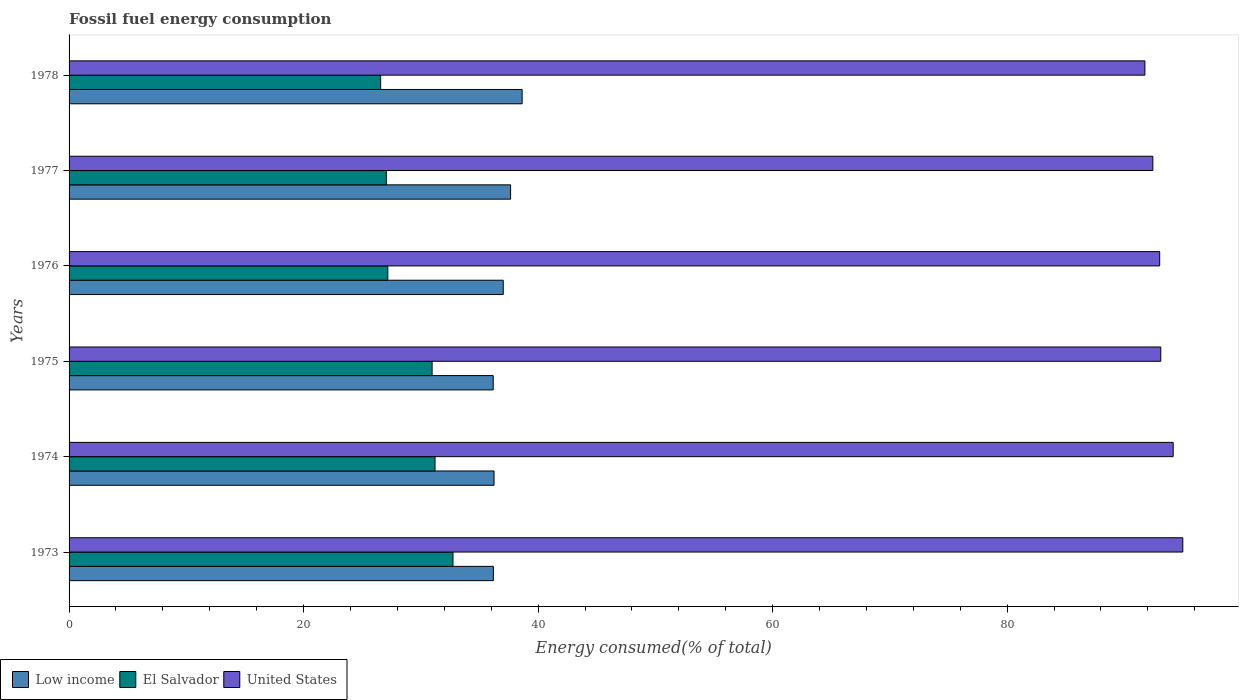How many different coloured bars are there?
Provide a short and direct response. 3. How many groups of bars are there?
Make the answer very short. 6. Are the number of bars per tick equal to the number of legend labels?
Offer a very short reply. Yes. How many bars are there on the 6th tick from the top?
Your answer should be compact. 3. What is the label of the 4th group of bars from the top?
Your answer should be very brief. 1975. In how many cases, is the number of bars for a given year not equal to the number of legend labels?
Keep it short and to the point. 0. What is the percentage of energy consumed in El Salvador in 1974?
Make the answer very short. 31.21. Across all years, what is the maximum percentage of energy consumed in United States?
Your answer should be compact. 94.98. Across all years, what is the minimum percentage of energy consumed in Low income?
Offer a very short reply. 36.17. In which year was the percentage of energy consumed in Low income maximum?
Your response must be concise. 1978. In which year was the percentage of energy consumed in Low income minimum?
Ensure brevity in your answer.  1975. What is the total percentage of energy consumed in United States in the graph?
Make the answer very short. 559.4. What is the difference between the percentage of energy consumed in El Salvador in 1973 and that in 1977?
Provide a short and direct response. 5.68. What is the difference between the percentage of energy consumed in El Salvador in 1977 and the percentage of energy consumed in Low income in 1973?
Offer a terse response. -9.13. What is the average percentage of energy consumed in El Salvador per year?
Offer a very short reply. 29.29. In the year 1978, what is the difference between the percentage of energy consumed in United States and percentage of energy consumed in Low income?
Offer a terse response. 53.11. In how many years, is the percentage of energy consumed in United States greater than 48 %?
Keep it short and to the point. 6. What is the ratio of the percentage of energy consumed in El Salvador in 1976 to that in 1978?
Your answer should be very brief. 1.02. Is the difference between the percentage of energy consumed in United States in 1974 and 1975 greater than the difference between the percentage of energy consumed in Low income in 1974 and 1975?
Provide a short and direct response. Yes. What is the difference between the highest and the second highest percentage of energy consumed in Low income?
Your response must be concise. 0.98. What is the difference between the highest and the lowest percentage of energy consumed in Low income?
Offer a terse response. 2.47. Is the sum of the percentage of energy consumed in El Salvador in 1974 and 1975 greater than the maximum percentage of energy consumed in United States across all years?
Your answer should be very brief. No. What does the 2nd bar from the top in 1975 represents?
Your answer should be very brief. El Salvador. What does the 2nd bar from the bottom in 1973 represents?
Your answer should be compact. El Salvador. Is it the case that in every year, the sum of the percentage of energy consumed in El Salvador and percentage of energy consumed in Low income is greater than the percentage of energy consumed in United States?
Offer a very short reply. No. How many bars are there?
Your response must be concise. 18. What is the difference between two consecutive major ticks on the X-axis?
Ensure brevity in your answer.  20. Does the graph contain any zero values?
Keep it short and to the point. No. Where does the legend appear in the graph?
Give a very brief answer. Bottom left. What is the title of the graph?
Make the answer very short. Fossil fuel energy consumption. Does "Thailand" appear as one of the legend labels in the graph?
Make the answer very short. No. What is the label or title of the X-axis?
Your answer should be very brief. Energy consumed(% of total). What is the label or title of the Y-axis?
Give a very brief answer. Years. What is the Energy consumed(% of total) in Low income in 1973?
Provide a short and direct response. 36.18. What is the Energy consumed(% of total) of El Salvador in 1973?
Provide a short and direct response. 32.74. What is the Energy consumed(% of total) of United States in 1973?
Provide a succinct answer. 94.98. What is the Energy consumed(% of total) of Low income in 1974?
Make the answer very short. 36.24. What is the Energy consumed(% of total) in El Salvador in 1974?
Provide a short and direct response. 31.21. What is the Energy consumed(% of total) in United States in 1974?
Offer a terse response. 94.16. What is the Energy consumed(% of total) of Low income in 1975?
Ensure brevity in your answer.  36.17. What is the Energy consumed(% of total) of El Salvador in 1975?
Provide a short and direct response. 30.96. What is the Energy consumed(% of total) in United States in 1975?
Make the answer very short. 93.1. What is the Energy consumed(% of total) in Low income in 1976?
Your response must be concise. 37.02. What is the Energy consumed(% of total) in El Salvador in 1976?
Your answer should be compact. 27.18. What is the Energy consumed(% of total) of United States in 1976?
Your response must be concise. 93.01. What is the Energy consumed(% of total) of Low income in 1977?
Your response must be concise. 37.65. What is the Energy consumed(% of total) of El Salvador in 1977?
Keep it short and to the point. 27.06. What is the Energy consumed(% of total) in United States in 1977?
Ensure brevity in your answer.  92.42. What is the Energy consumed(% of total) in Low income in 1978?
Offer a terse response. 38.64. What is the Energy consumed(% of total) in El Salvador in 1978?
Your answer should be compact. 26.57. What is the Energy consumed(% of total) in United States in 1978?
Offer a very short reply. 91.74. Across all years, what is the maximum Energy consumed(% of total) in Low income?
Your response must be concise. 38.64. Across all years, what is the maximum Energy consumed(% of total) of El Salvador?
Ensure brevity in your answer.  32.74. Across all years, what is the maximum Energy consumed(% of total) of United States?
Your answer should be compact. 94.98. Across all years, what is the minimum Energy consumed(% of total) of Low income?
Offer a terse response. 36.17. Across all years, what is the minimum Energy consumed(% of total) of El Salvador?
Offer a very short reply. 26.57. Across all years, what is the minimum Energy consumed(% of total) of United States?
Your answer should be compact. 91.74. What is the total Energy consumed(% of total) in Low income in the graph?
Provide a short and direct response. 221.91. What is the total Energy consumed(% of total) in El Salvador in the graph?
Your answer should be very brief. 175.72. What is the total Energy consumed(% of total) in United States in the graph?
Your answer should be very brief. 559.4. What is the difference between the Energy consumed(% of total) in Low income in 1973 and that in 1974?
Your response must be concise. -0.06. What is the difference between the Energy consumed(% of total) in El Salvador in 1973 and that in 1974?
Ensure brevity in your answer.  1.53. What is the difference between the Energy consumed(% of total) of United States in 1973 and that in 1974?
Ensure brevity in your answer.  0.82. What is the difference between the Energy consumed(% of total) in Low income in 1973 and that in 1975?
Your answer should be very brief. 0.02. What is the difference between the Energy consumed(% of total) in El Salvador in 1973 and that in 1975?
Provide a succinct answer. 1.78. What is the difference between the Energy consumed(% of total) in United States in 1973 and that in 1975?
Provide a short and direct response. 1.88. What is the difference between the Energy consumed(% of total) of Low income in 1973 and that in 1976?
Your response must be concise. -0.84. What is the difference between the Energy consumed(% of total) of El Salvador in 1973 and that in 1976?
Ensure brevity in your answer.  5.56. What is the difference between the Energy consumed(% of total) of United States in 1973 and that in 1976?
Give a very brief answer. 1.97. What is the difference between the Energy consumed(% of total) of Low income in 1973 and that in 1977?
Give a very brief answer. -1.47. What is the difference between the Energy consumed(% of total) in El Salvador in 1973 and that in 1977?
Offer a terse response. 5.68. What is the difference between the Energy consumed(% of total) of United States in 1973 and that in 1977?
Ensure brevity in your answer.  2.55. What is the difference between the Energy consumed(% of total) in Low income in 1973 and that in 1978?
Offer a terse response. -2.45. What is the difference between the Energy consumed(% of total) in El Salvador in 1973 and that in 1978?
Provide a short and direct response. 6.17. What is the difference between the Energy consumed(% of total) in United States in 1973 and that in 1978?
Provide a short and direct response. 3.23. What is the difference between the Energy consumed(% of total) in Low income in 1974 and that in 1975?
Ensure brevity in your answer.  0.07. What is the difference between the Energy consumed(% of total) of El Salvador in 1974 and that in 1975?
Your response must be concise. 0.25. What is the difference between the Energy consumed(% of total) of United States in 1974 and that in 1975?
Your answer should be compact. 1.06. What is the difference between the Energy consumed(% of total) in Low income in 1974 and that in 1976?
Your response must be concise. -0.79. What is the difference between the Energy consumed(% of total) of El Salvador in 1974 and that in 1976?
Keep it short and to the point. 4.03. What is the difference between the Energy consumed(% of total) in United States in 1974 and that in 1976?
Your answer should be very brief. 1.15. What is the difference between the Energy consumed(% of total) in Low income in 1974 and that in 1977?
Provide a short and direct response. -1.41. What is the difference between the Energy consumed(% of total) of El Salvador in 1974 and that in 1977?
Provide a short and direct response. 4.15. What is the difference between the Energy consumed(% of total) of United States in 1974 and that in 1977?
Offer a terse response. 1.73. What is the difference between the Energy consumed(% of total) in Low income in 1974 and that in 1978?
Make the answer very short. -2.4. What is the difference between the Energy consumed(% of total) in El Salvador in 1974 and that in 1978?
Ensure brevity in your answer.  4.64. What is the difference between the Energy consumed(% of total) of United States in 1974 and that in 1978?
Your response must be concise. 2.41. What is the difference between the Energy consumed(% of total) of Low income in 1975 and that in 1976?
Offer a terse response. -0.86. What is the difference between the Energy consumed(% of total) in El Salvador in 1975 and that in 1976?
Ensure brevity in your answer.  3.78. What is the difference between the Energy consumed(% of total) of United States in 1975 and that in 1976?
Your answer should be compact. 0.09. What is the difference between the Energy consumed(% of total) of Low income in 1975 and that in 1977?
Ensure brevity in your answer.  -1.48. What is the difference between the Energy consumed(% of total) in El Salvador in 1975 and that in 1977?
Offer a very short reply. 3.9. What is the difference between the Energy consumed(% of total) in United States in 1975 and that in 1977?
Your response must be concise. 0.68. What is the difference between the Energy consumed(% of total) in Low income in 1975 and that in 1978?
Offer a very short reply. -2.47. What is the difference between the Energy consumed(% of total) of El Salvador in 1975 and that in 1978?
Offer a terse response. 4.39. What is the difference between the Energy consumed(% of total) of United States in 1975 and that in 1978?
Give a very brief answer. 1.35. What is the difference between the Energy consumed(% of total) of Low income in 1976 and that in 1977?
Ensure brevity in your answer.  -0.63. What is the difference between the Energy consumed(% of total) in El Salvador in 1976 and that in 1977?
Give a very brief answer. 0.13. What is the difference between the Energy consumed(% of total) of United States in 1976 and that in 1977?
Offer a very short reply. 0.58. What is the difference between the Energy consumed(% of total) in Low income in 1976 and that in 1978?
Give a very brief answer. -1.61. What is the difference between the Energy consumed(% of total) of El Salvador in 1976 and that in 1978?
Offer a very short reply. 0.61. What is the difference between the Energy consumed(% of total) of United States in 1976 and that in 1978?
Provide a short and direct response. 1.26. What is the difference between the Energy consumed(% of total) in Low income in 1977 and that in 1978?
Ensure brevity in your answer.  -0.98. What is the difference between the Energy consumed(% of total) in El Salvador in 1977 and that in 1978?
Offer a terse response. 0.49. What is the difference between the Energy consumed(% of total) of United States in 1977 and that in 1978?
Make the answer very short. 0.68. What is the difference between the Energy consumed(% of total) in Low income in 1973 and the Energy consumed(% of total) in El Salvador in 1974?
Give a very brief answer. 4.98. What is the difference between the Energy consumed(% of total) in Low income in 1973 and the Energy consumed(% of total) in United States in 1974?
Your response must be concise. -57.97. What is the difference between the Energy consumed(% of total) of El Salvador in 1973 and the Energy consumed(% of total) of United States in 1974?
Offer a very short reply. -61.42. What is the difference between the Energy consumed(% of total) of Low income in 1973 and the Energy consumed(% of total) of El Salvador in 1975?
Give a very brief answer. 5.22. What is the difference between the Energy consumed(% of total) in Low income in 1973 and the Energy consumed(% of total) in United States in 1975?
Your answer should be very brief. -56.91. What is the difference between the Energy consumed(% of total) of El Salvador in 1973 and the Energy consumed(% of total) of United States in 1975?
Your answer should be compact. -60.36. What is the difference between the Energy consumed(% of total) in Low income in 1973 and the Energy consumed(% of total) in El Salvador in 1976?
Your response must be concise. 9. What is the difference between the Energy consumed(% of total) in Low income in 1973 and the Energy consumed(% of total) in United States in 1976?
Provide a short and direct response. -56.82. What is the difference between the Energy consumed(% of total) in El Salvador in 1973 and the Energy consumed(% of total) in United States in 1976?
Provide a short and direct response. -60.27. What is the difference between the Energy consumed(% of total) in Low income in 1973 and the Energy consumed(% of total) in El Salvador in 1977?
Provide a short and direct response. 9.13. What is the difference between the Energy consumed(% of total) of Low income in 1973 and the Energy consumed(% of total) of United States in 1977?
Keep it short and to the point. -56.24. What is the difference between the Energy consumed(% of total) in El Salvador in 1973 and the Energy consumed(% of total) in United States in 1977?
Keep it short and to the point. -59.68. What is the difference between the Energy consumed(% of total) of Low income in 1973 and the Energy consumed(% of total) of El Salvador in 1978?
Your response must be concise. 9.61. What is the difference between the Energy consumed(% of total) of Low income in 1973 and the Energy consumed(% of total) of United States in 1978?
Provide a succinct answer. -55.56. What is the difference between the Energy consumed(% of total) in El Salvador in 1973 and the Energy consumed(% of total) in United States in 1978?
Give a very brief answer. -59. What is the difference between the Energy consumed(% of total) in Low income in 1974 and the Energy consumed(% of total) in El Salvador in 1975?
Offer a terse response. 5.28. What is the difference between the Energy consumed(% of total) of Low income in 1974 and the Energy consumed(% of total) of United States in 1975?
Ensure brevity in your answer.  -56.86. What is the difference between the Energy consumed(% of total) of El Salvador in 1974 and the Energy consumed(% of total) of United States in 1975?
Provide a short and direct response. -61.89. What is the difference between the Energy consumed(% of total) of Low income in 1974 and the Energy consumed(% of total) of El Salvador in 1976?
Provide a succinct answer. 9.06. What is the difference between the Energy consumed(% of total) of Low income in 1974 and the Energy consumed(% of total) of United States in 1976?
Provide a short and direct response. -56.77. What is the difference between the Energy consumed(% of total) of El Salvador in 1974 and the Energy consumed(% of total) of United States in 1976?
Make the answer very short. -61.8. What is the difference between the Energy consumed(% of total) in Low income in 1974 and the Energy consumed(% of total) in El Salvador in 1977?
Offer a very short reply. 9.18. What is the difference between the Energy consumed(% of total) in Low income in 1974 and the Energy consumed(% of total) in United States in 1977?
Ensure brevity in your answer.  -56.18. What is the difference between the Energy consumed(% of total) in El Salvador in 1974 and the Energy consumed(% of total) in United States in 1977?
Offer a terse response. -61.21. What is the difference between the Energy consumed(% of total) in Low income in 1974 and the Energy consumed(% of total) in El Salvador in 1978?
Offer a terse response. 9.67. What is the difference between the Energy consumed(% of total) of Low income in 1974 and the Energy consumed(% of total) of United States in 1978?
Your answer should be very brief. -55.5. What is the difference between the Energy consumed(% of total) in El Salvador in 1974 and the Energy consumed(% of total) in United States in 1978?
Offer a very short reply. -60.54. What is the difference between the Energy consumed(% of total) in Low income in 1975 and the Energy consumed(% of total) in El Salvador in 1976?
Ensure brevity in your answer.  8.99. What is the difference between the Energy consumed(% of total) in Low income in 1975 and the Energy consumed(% of total) in United States in 1976?
Your answer should be compact. -56.84. What is the difference between the Energy consumed(% of total) in El Salvador in 1975 and the Energy consumed(% of total) in United States in 1976?
Offer a very short reply. -62.05. What is the difference between the Energy consumed(% of total) in Low income in 1975 and the Energy consumed(% of total) in El Salvador in 1977?
Make the answer very short. 9.11. What is the difference between the Energy consumed(% of total) of Low income in 1975 and the Energy consumed(% of total) of United States in 1977?
Provide a succinct answer. -56.25. What is the difference between the Energy consumed(% of total) of El Salvador in 1975 and the Energy consumed(% of total) of United States in 1977?
Provide a short and direct response. -61.46. What is the difference between the Energy consumed(% of total) in Low income in 1975 and the Energy consumed(% of total) in El Salvador in 1978?
Your response must be concise. 9.6. What is the difference between the Energy consumed(% of total) in Low income in 1975 and the Energy consumed(% of total) in United States in 1978?
Offer a very short reply. -55.58. What is the difference between the Energy consumed(% of total) in El Salvador in 1975 and the Energy consumed(% of total) in United States in 1978?
Offer a very short reply. -60.78. What is the difference between the Energy consumed(% of total) of Low income in 1976 and the Energy consumed(% of total) of El Salvador in 1977?
Provide a succinct answer. 9.97. What is the difference between the Energy consumed(% of total) of Low income in 1976 and the Energy consumed(% of total) of United States in 1977?
Your answer should be compact. -55.4. What is the difference between the Energy consumed(% of total) of El Salvador in 1976 and the Energy consumed(% of total) of United States in 1977?
Provide a succinct answer. -65.24. What is the difference between the Energy consumed(% of total) in Low income in 1976 and the Energy consumed(% of total) in El Salvador in 1978?
Your answer should be compact. 10.45. What is the difference between the Energy consumed(% of total) in Low income in 1976 and the Energy consumed(% of total) in United States in 1978?
Your answer should be compact. -54.72. What is the difference between the Energy consumed(% of total) of El Salvador in 1976 and the Energy consumed(% of total) of United States in 1978?
Provide a succinct answer. -64.56. What is the difference between the Energy consumed(% of total) of Low income in 1977 and the Energy consumed(% of total) of El Salvador in 1978?
Provide a succinct answer. 11.08. What is the difference between the Energy consumed(% of total) in Low income in 1977 and the Energy consumed(% of total) in United States in 1978?
Offer a terse response. -54.09. What is the difference between the Energy consumed(% of total) in El Salvador in 1977 and the Energy consumed(% of total) in United States in 1978?
Provide a short and direct response. -64.69. What is the average Energy consumed(% of total) of Low income per year?
Provide a succinct answer. 36.98. What is the average Energy consumed(% of total) of El Salvador per year?
Offer a very short reply. 29.29. What is the average Energy consumed(% of total) of United States per year?
Your answer should be very brief. 93.23. In the year 1973, what is the difference between the Energy consumed(% of total) of Low income and Energy consumed(% of total) of El Salvador?
Provide a succinct answer. 3.44. In the year 1973, what is the difference between the Energy consumed(% of total) of Low income and Energy consumed(% of total) of United States?
Provide a succinct answer. -58.79. In the year 1973, what is the difference between the Energy consumed(% of total) in El Salvador and Energy consumed(% of total) in United States?
Offer a very short reply. -62.24. In the year 1974, what is the difference between the Energy consumed(% of total) in Low income and Energy consumed(% of total) in El Salvador?
Offer a terse response. 5.03. In the year 1974, what is the difference between the Energy consumed(% of total) in Low income and Energy consumed(% of total) in United States?
Offer a very short reply. -57.92. In the year 1974, what is the difference between the Energy consumed(% of total) of El Salvador and Energy consumed(% of total) of United States?
Your answer should be very brief. -62.95. In the year 1975, what is the difference between the Energy consumed(% of total) in Low income and Energy consumed(% of total) in El Salvador?
Your answer should be compact. 5.21. In the year 1975, what is the difference between the Energy consumed(% of total) in Low income and Energy consumed(% of total) in United States?
Ensure brevity in your answer.  -56.93. In the year 1975, what is the difference between the Energy consumed(% of total) of El Salvador and Energy consumed(% of total) of United States?
Offer a terse response. -62.14. In the year 1976, what is the difference between the Energy consumed(% of total) of Low income and Energy consumed(% of total) of El Salvador?
Ensure brevity in your answer.  9.84. In the year 1976, what is the difference between the Energy consumed(% of total) in Low income and Energy consumed(% of total) in United States?
Offer a terse response. -55.98. In the year 1976, what is the difference between the Energy consumed(% of total) in El Salvador and Energy consumed(% of total) in United States?
Your response must be concise. -65.82. In the year 1977, what is the difference between the Energy consumed(% of total) of Low income and Energy consumed(% of total) of El Salvador?
Give a very brief answer. 10.6. In the year 1977, what is the difference between the Energy consumed(% of total) in Low income and Energy consumed(% of total) in United States?
Provide a short and direct response. -54.77. In the year 1977, what is the difference between the Energy consumed(% of total) of El Salvador and Energy consumed(% of total) of United States?
Provide a short and direct response. -65.37. In the year 1978, what is the difference between the Energy consumed(% of total) in Low income and Energy consumed(% of total) in El Salvador?
Offer a terse response. 12.07. In the year 1978, what is the difference between the Energy consumed(% of total) in Low income and Energy consumed(% of total) in United States?
Give a very brief answer. -53.11. In the year 1978, what is the difference between the Energy consumed(% of total) of El Salvador and Energy consumed(% of total) of United States?
Provide a short and direct response. -65.17. What is the ratio of the Energy consumed(% of total) of Low income in 1973 to that in 1974?
Offer a very short reply. 1. What is the ratio of the Energy consumed(% of total) of El Salvador in 1973 to that in 1974?
Provide a succinct answer. 1.05. What is the ratio of the Energy consumed(% of total) of United States in 1973 to that in 1974?
Ensure brevity in your answer.  1.01. What is the ratio of the Energy consumed(% of total) in Low income in 1973 to that in 1975?
Your answer should be very brief. 1. What is the ratio of the Energy consumed(% of total) of El Salvador in 1973 to that in 1975?
Offer a very short reply. 1.06. What is the ratio of the Energy consumed(% of total) in United States in 1973 to that in 1975?
Provide a succinct answer. 1.02. What is the ratio of the Energy consumed(% of total) in Low income in 1973 to that in 1976?
Your response must be concise. 0.98. What is the ratio of the Energy consumed(% of total) in El Salvador in 1973 to that in 1976?
Provide a short and direct response. 1.2. What is the ratio of the Energy consumed(% of total) of United States in 1973 to that in 1976?
Ensure brevity in your answer.  1.02. What is the ratio of the Energy consumed(% of total) in Low income in 1973 to that in 1977?
Provide a succinct answer. 0.96. What is the ratio of the Energy consumed(% of total) in El Salvador in 1973 to that in 1977?
Keep it short and to the point. 1.21. What is the ratio of the Energy consumed(% of total) in United States in 1973 to that in 1977?
Give a very brief answer. 1.03. What is the ratio of the Energy consumed(% of total) of Low income in 1973 to that in 1978?
Keep it short and to the point. 0.94. What is the ratio of the Energy consumed(% of total) of El Salvador in 1973 to that in 1978?
Your answer should be compact. 1.23. What is the ratio of the Energy consumed(% of total) in United States in 1973 to that in 1978?
Ensure brevity in your answer.  1.04. What is the ratio of the Energy consumed(% of total) of United States in 1974 to that in 1975?
Your answer should be very brief. 1.01. What is the ratio of the Energy consumed(% of total) of Low income in 1974 to that in 1976?
Your response must be concise. 0.98. What is the ratio of the Energy consumed(% of total) in El Salvador in 1974 to that in 1976?
Your answer should be very brief. 1.15. What is the ratio of the Energy consumed(% of total) of United States in 1974 to that in 1976?
Provide a succinct answer. 1.01. What is the ratio of the Energy consumed(% of total) of Low income in 1974 to that in 1977?
Provide a succinct answer. 0.96. What is the ratio of the Energy consumed(% of total) of El Salvador in 1974 to that in 1977?
Offer a terse response. 1.15. What is the ratio of the Energy consumed(% of total) of United States in 1974 to that in 1977?
Your answer should be very brief. 1.02. What is the ratio of the Energy consumed(% of total) in Low income in 1974 to that in 1978?
Ensure brevity in your answer.  0.94. What is the ratio of the Energy consumed(% of total) in El Salvador in 1974 to that in 1978?
Make the answer very short. 1.17. What is the ratio of the Energy consumed(% of total) of United States in 1974 to that in 1978?
Provide a succinct answer. 1.03. What is the ratio of the Energy consumed(% of total) in Low income in 1975 to that in 1976?
Make the answer very short. 0.98. What is the ratio of the Energy consumed(% of total) in El Salvador in 1975 to that in 1976?
Provide a succinct answer. 1.14. What is the ratio of the Energy consumed(% of total) of Low income in 1975 to that in 1977?
Give a very brief answer. 0.96. What is the ratio of the Energy consumed(% of total) in El Salvador in 1975 to that in 1977?
Give a very brief answer. 1.14. What is the ratio of the Energy consumed(% of total) of United States in 1975 to that in 1977?
Your response must be concise. 1.01. What is the ratio of the Energy consumed(% of total) in Low income in 1975 to that in 1978?
Your answer should be compact. 0.94. What is the ratio of the Energy consumed(% of total) in El Salvador in 1975 to that in 1978?
Offer a terse response. 1.17. What is the ratio of the Energy consumed(% of total) of United States in 1975 to that in 1978?
Your answer should be compact. 1.01. What is the ratio of the Energy consumed(% of total) of Low income in 1976 to that in 1977?
Provide a short and direct response. 0.98. What is the ratio of the Energy consumed(% of total) in United States in 1976 to that in 1977?
Your response must be concise. 1.01. What is the ratio of the Energy consumed(% of total) of United States in 1976 to that in 1978?
Ensure brevity in your answer.  1.01. What is the ratio of the Energy consumed(% of total) in Low income in 1977 to that in 1978?
Make the answer very short. 0.97. What is the ratio of the Energy consumed(% of total) of El Salvador in 1977 to that in 1978?
Provide a succinct answer. 1.02. What is the ratio of the Energy consumed(% of total) of United States in 1977 to that in 1978?
Keep it short and to the point. 1.01. What is the difference between the highest and the second highest Energy consumed(% of total) in Low income?
Keep it short and to the point. 0.98. What is the difference between the highest and the second highest Energy consumed(% of total) in El Salvador?
Keep it short and to the point. 1.53. What is the difference between the highest and the second highest Energy consumed(% of total) in United States?
Offer a very short reply. 0.82. What is the difference between the highest and the lowest Energy consumed(% of total) in Low income?
Provide a short and direct response. 2.47. What is the difference between the highest and the lowest Energy consumed(% of total) of El Salvador?
Provide a succinct answer. 6.17. What is the difference between the highest and the lowest Energy consumed(% of total) of United States?
Offer a very short reply. 3.23. 